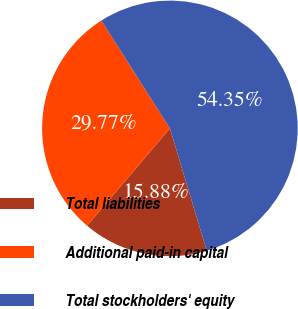<chart> <loc_0><loc_0><loc_500><loc_500><pie_chart><fcel>Total liabilities<fcel>Additional paid-in capital<fcel>Total stockholders' equity<nl><fcel>15.88%<fcel>29.77%<fcel>54.34%<nl></chart> 